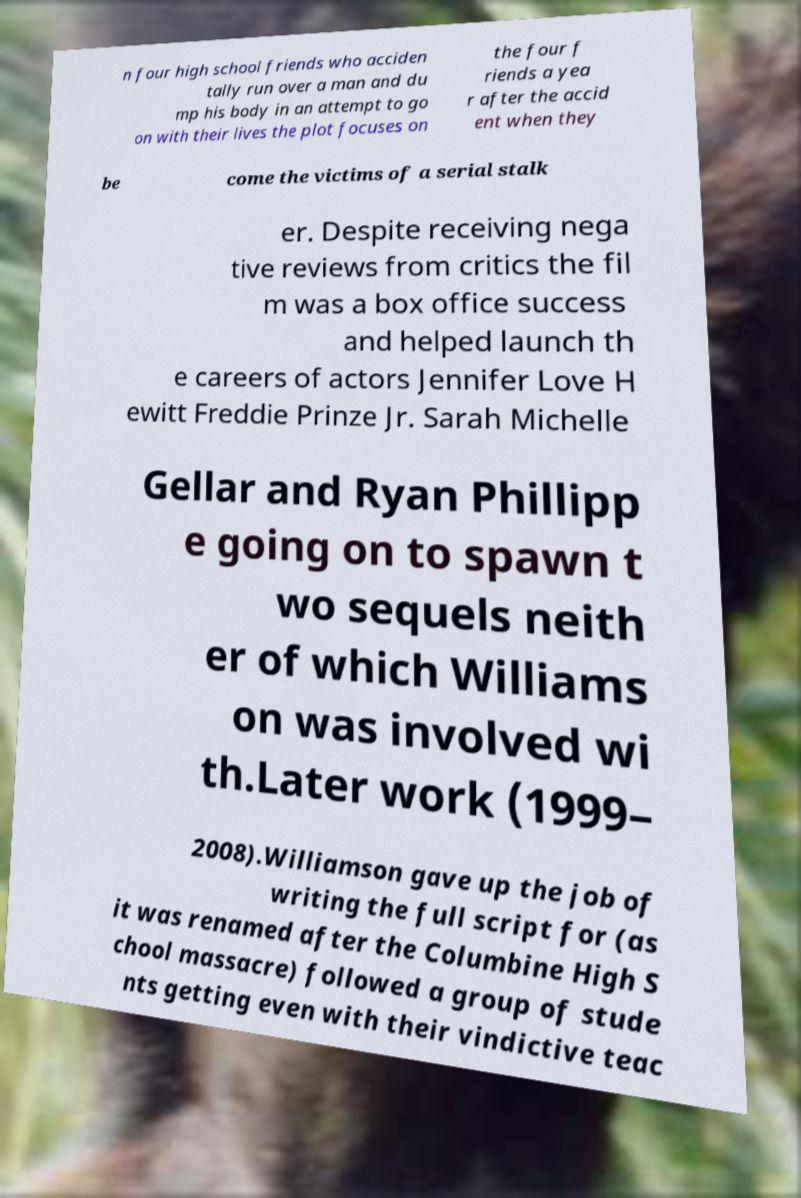What messages or text are displayed in this image? I need them in a readable, typed format. n four high school friends who acciden tally run over a man and du mp his body in an attempt to go on with their lives the plot focuses on the four f riends a yea r after the accid ent when they be come the victims of a serial stalk er. Despite receiving nega tive reviews from critics the fil m was a box office success and helped launch th e careers of actors Jennifer Love H ewitt Freddie Prinze Jr. Sarah Michelle Gellar and Ryan Phillipp e going on to spawn t wo sequels neith er of which Williams on was involved wi th.Later work (1999– 2008).Williamson gave up the job of writing the full script for (as it was renamed after the Columbine High S chool massacre) followed a group of stude nts getting even with their vindictive teac 